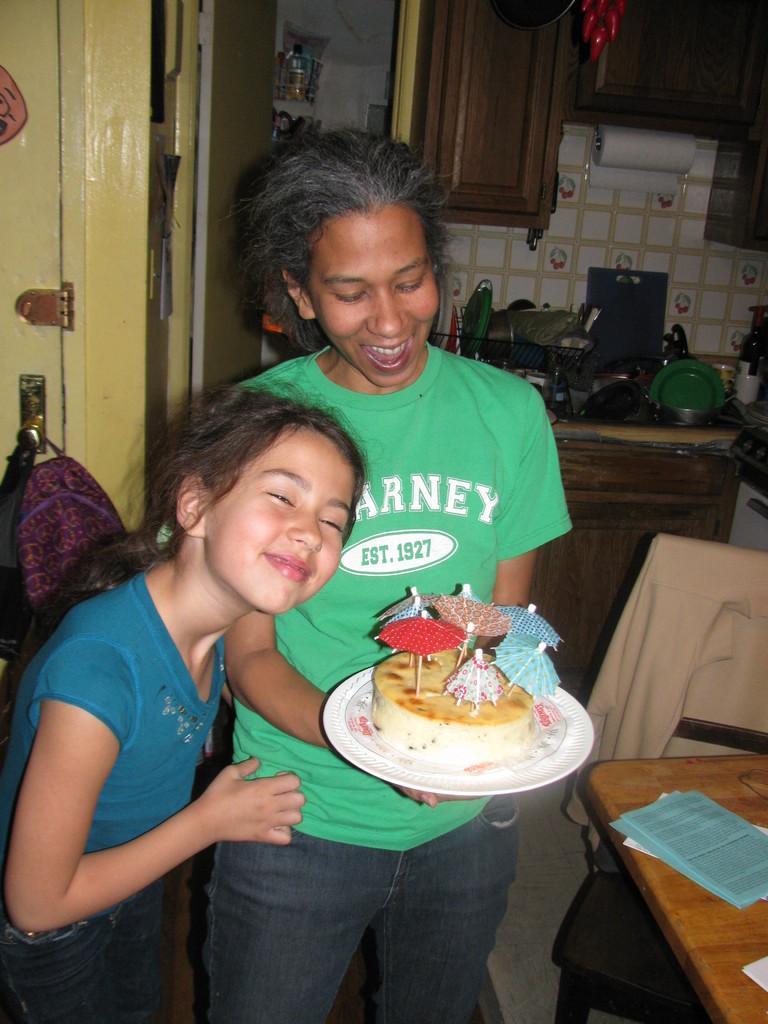How would you summarize this image in a sentence or two? There are two members in the picture. A small girl and a woman. Woman is holding a cake in her hands. In the background there is a tissue roll and some dishes. To the right of the woman there is paper on the table. 